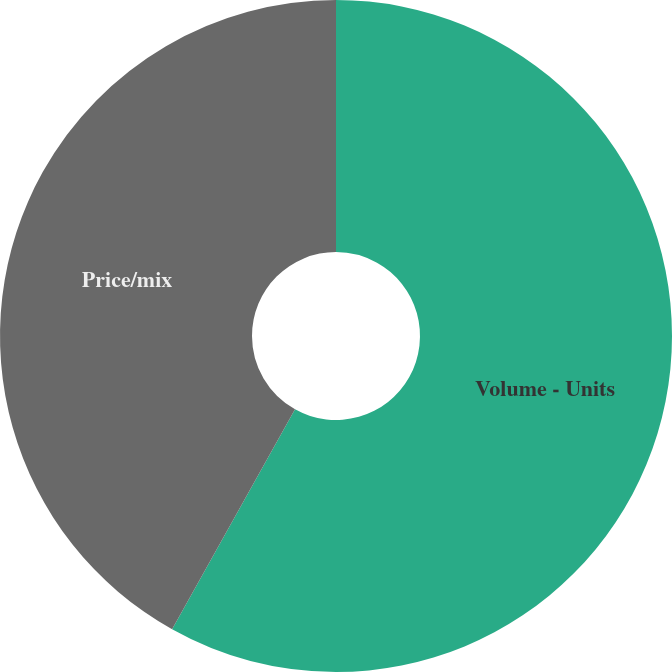<chart> <loc_0><loc_0><loc_500><loc_500><pie_chart><fcel>Volume - Units<fcel>Price/mix<nl><fcel>58.11%<fcel>41.89%<nl></chart> 